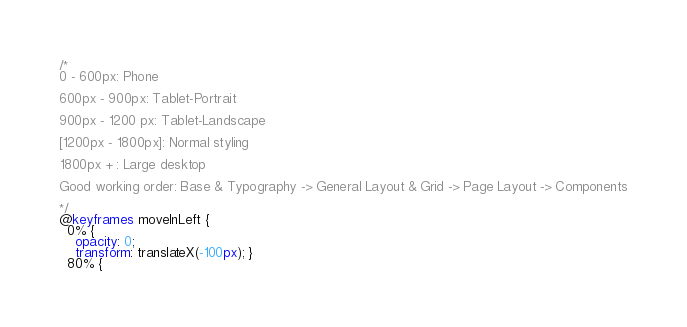<code> <loc_0><loc_0><loc_500><loc_500><_CSS_>/*
0 - 600px: Phone

600px - 900px: Tablet-Portrait

900px - 1200 px: Tablet-Landscape

[1200px - 1800px]: Normal styling

1800px + : Large desktop

Good working order: Base & Typography -> General Layout & Grid -> Page Layout -> Components

*/
@keyframes moveInLeft {
  0% {
    opacity: 0;
    transform: translateX(-100px); }
  80% {</code> 